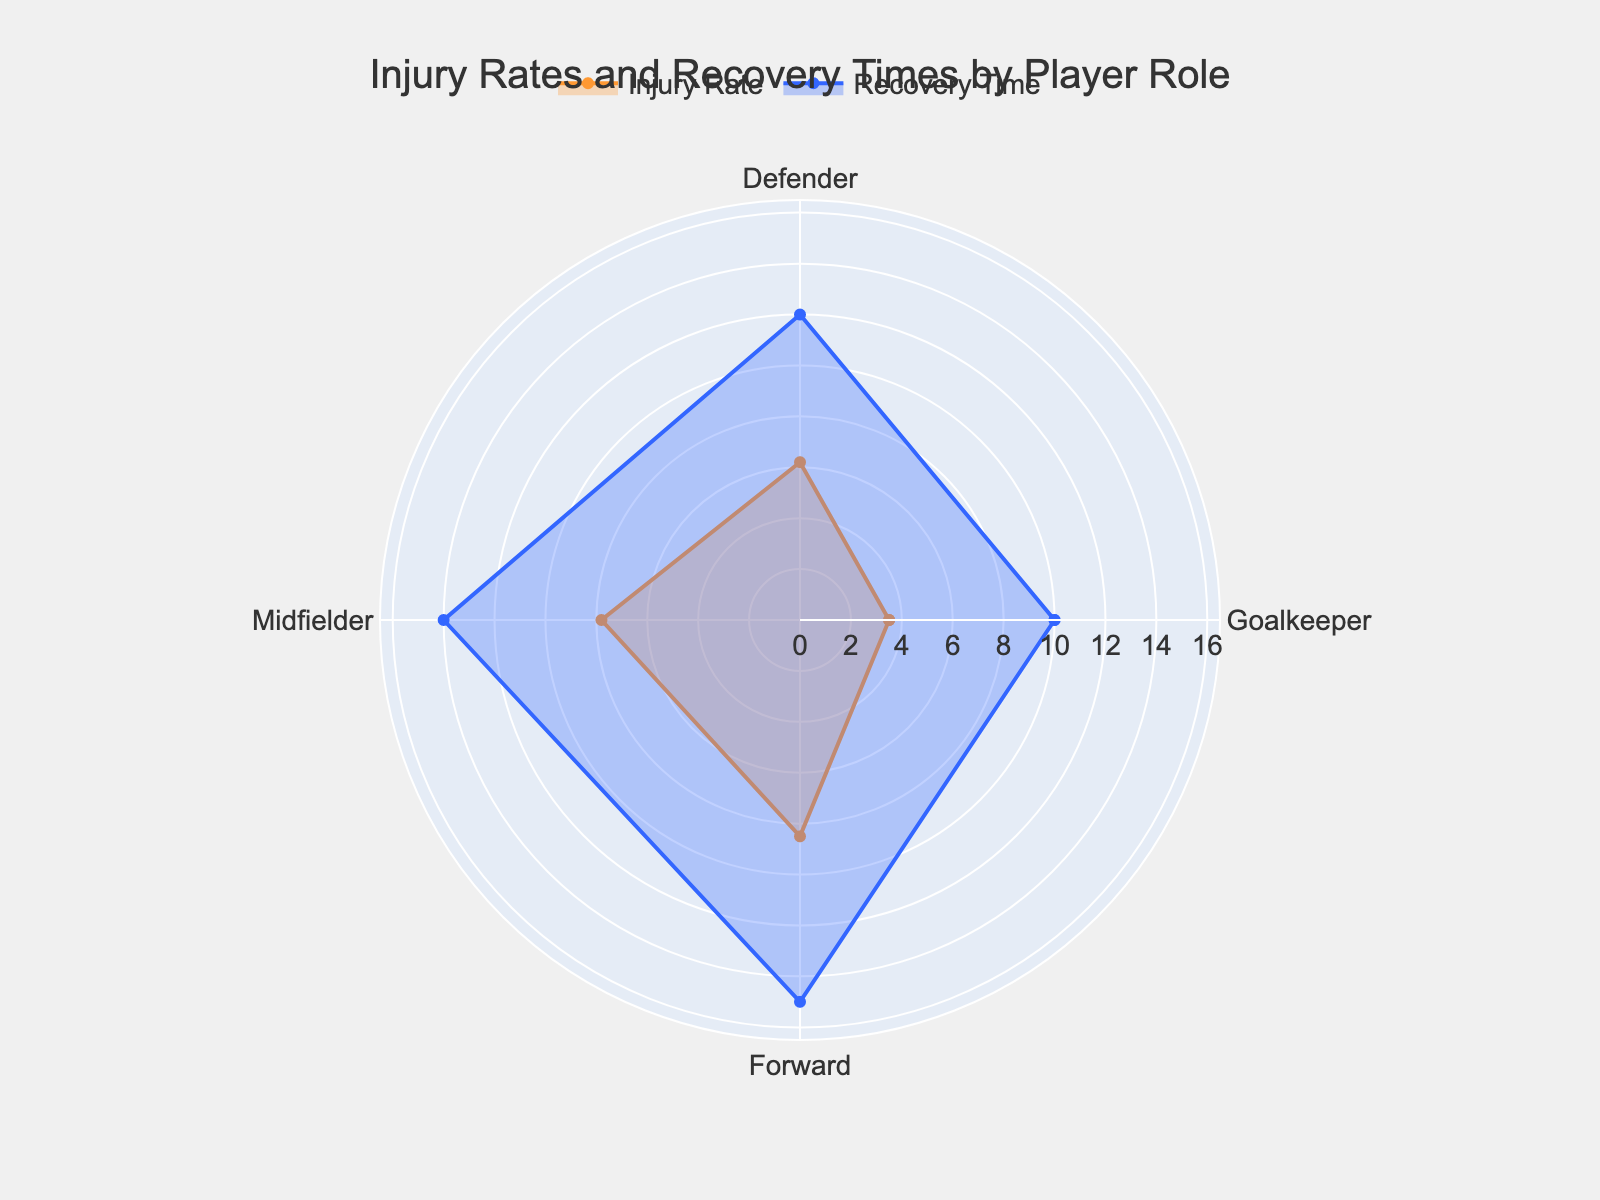What's the injury rate for Goalkeepers? The injury rate for goalkeepers can be directly read from the "Injury Rate" plot segment. According to the figure, the injury rate is displayed near the Goalkeeper label.
Answer: 3.5 How does the average recovery time for Midfielders compare to that for Defenders? To compare their recovery times, look at the "Recovery Time" plot segment values for Midfielders and Defenders on the chart. Midfielders have a recovery time of 14 weeks, while Defenders have 12 weeks.
Answer: Midfielders have 2 more weeks of recovery time than Defenders What is the average injury rate of all player roles shown? The injury rates are provided for Goalkeeper (3.5), Defender (6.2), Midfielder (7.8), and Forward (8.5). Summing them: 3.5 + 6.2 + 7.8 + 8.5 = 26. Calculating the average: 26 / 4 = 6.5
Answer: 6.5 Which player role has the highest average recovery time? Look at the recovery times plotted on the "Recovery Time" segment. The Forward has the highest recovery time of 15 weeks.
Answer: Forward Is the injury rate higher for Defenders or Forward players? By observing the "Injury Rate" plot segment, Defenders have an injury rate of 6.2, while Forwards have 8.5. Therefore, Forwards have a higher injury rate.
Answer: Forward players What's the overall title of the radar chart? The title can be seen at the top of the chart. The title is: "Injury Rates and Recovery Times by Player Role".
Answer: Injury Rates and Recovery Times by Player Role Do all player roles have an injury rate below 9? Referencing the "Injury Rate" plot segment, while Goalkeeper (3.5), Defender (6.2), and Midfielder (7.8) are below 9, Forward has an injury rate of 8.5 which is also less than 9. Therefore, yes.
Answer: Yes 